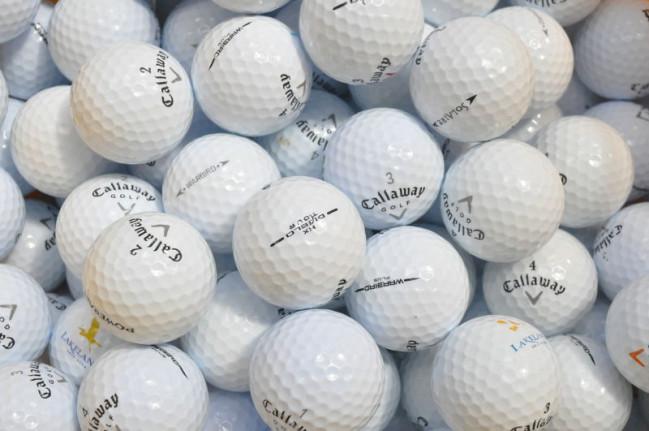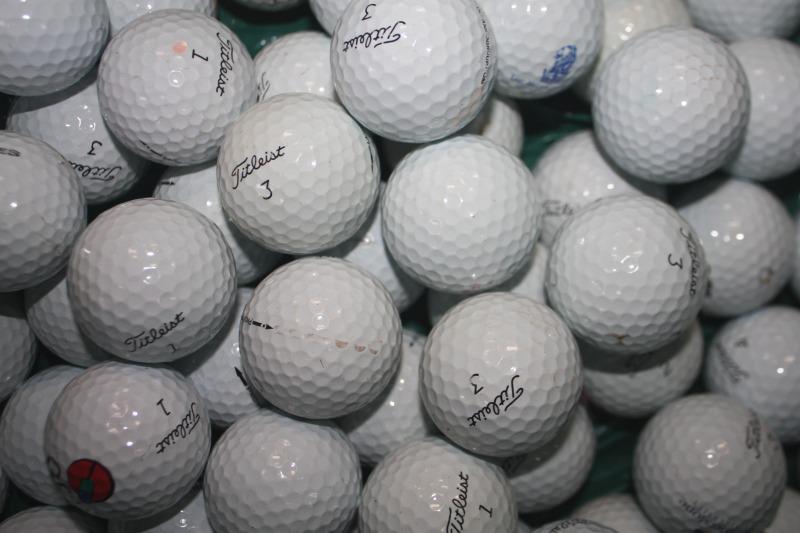The first image is the image on the left, the second image is the image on the right. For the images shown, is this caption "The golfballs in the image on the right are not in shadow." true? Answer yes or no. No. 